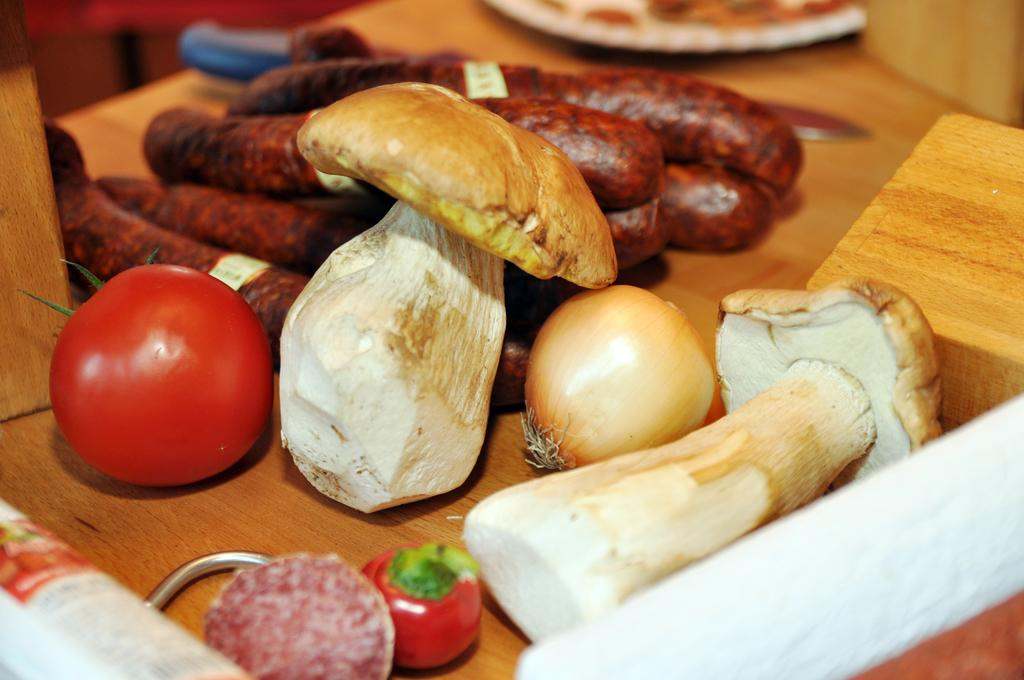What type of food items can be seen in the image? There are mushrooms, tomatoes, and an onion in the image. Are there any other food items present besides these? Yes, there are other food items in the image. What surface can be seen in the image? The wooden surface is present in the image. What type of room is depicted in the image? There is no room depicted in the image; it only shows food items and a wooden surface. Who is the representative of the food items in the image? There is no representative present in the image; it is a still life of food items. 